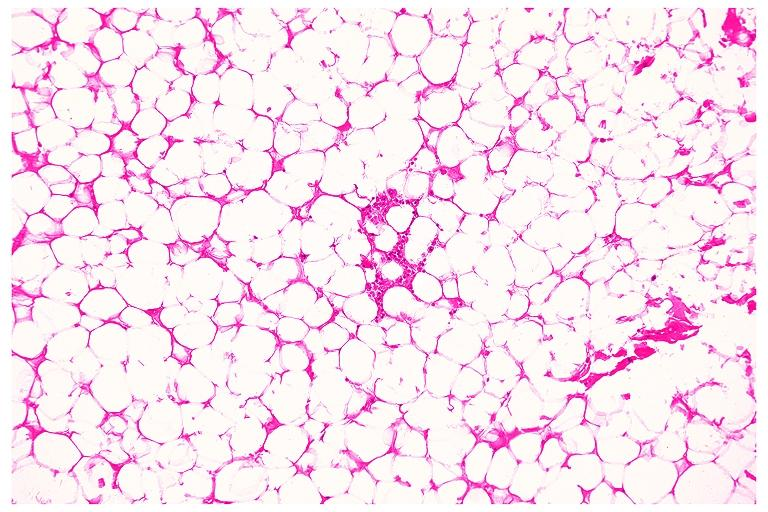what does this image show?
Answer the question using a single word or phrase. Lipoma 